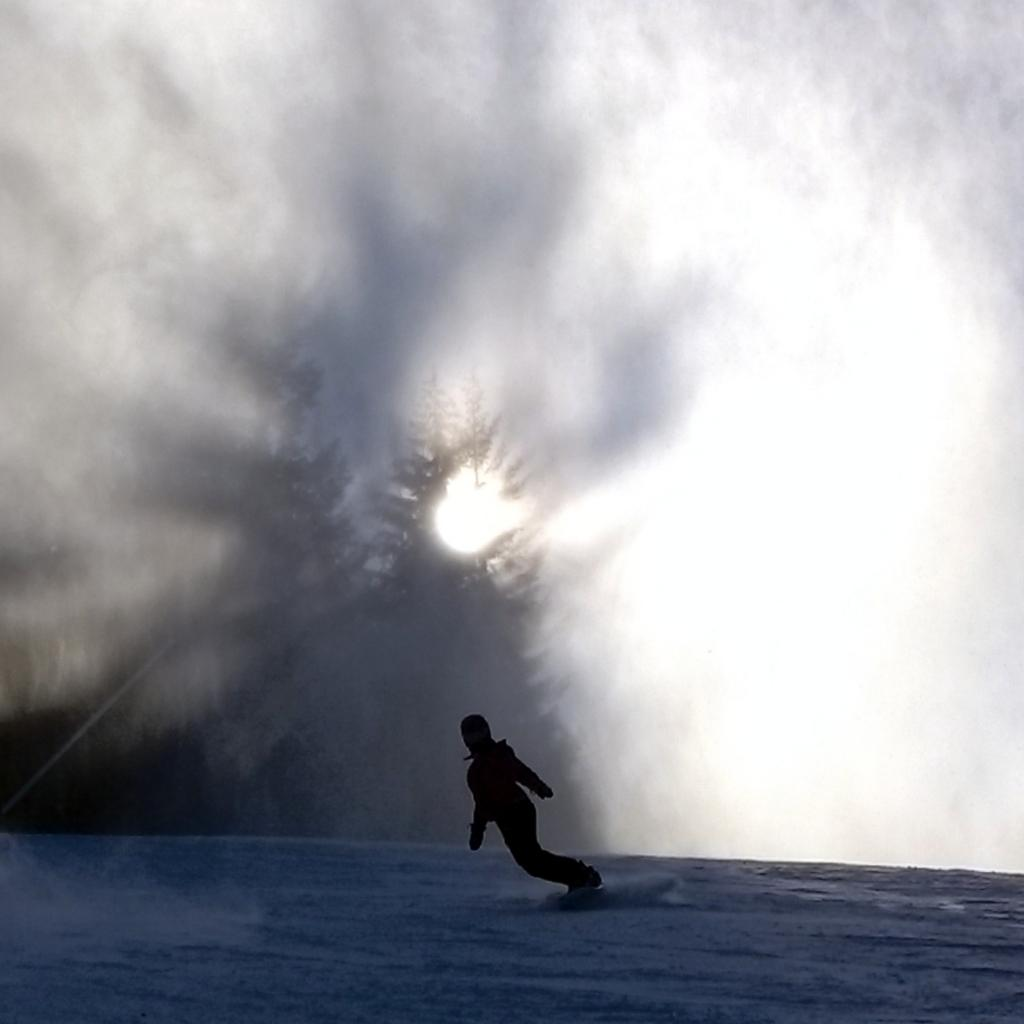What activity is the person in the image engaged in? The person is skiing in the image. What color is the person's shadow? The person's shadow is black. On what surface is the skiing taking place? The skiing is taking place on snow. What can be seen in the background of the image? There is sky and trees visible in the background of the image. What celestial body is observable in the sky? The sun is observable in the sky. What type of governor is the person skiing with in the image? There is no governor present in the image; the person is skiing alone. What is the name of the partner the person is skiing with in the image? There is no partner present in the image; the person is skiing alone. 